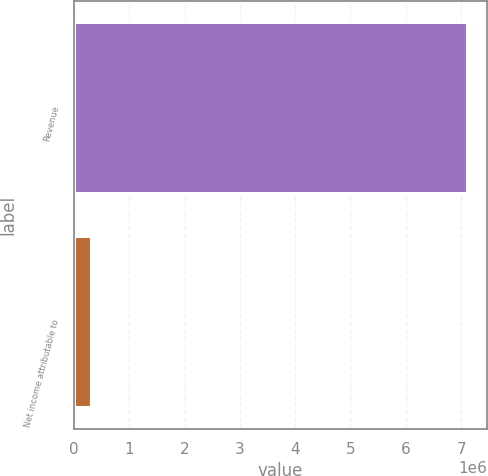Convert chart. <chart><loc_0><loc_0><loc_500><loc_500><bar_chart><fcel>Revenue<fcel>Net income attributable to<nl><fcel>7.11069e+06<fcel>301331<nl></chart> 